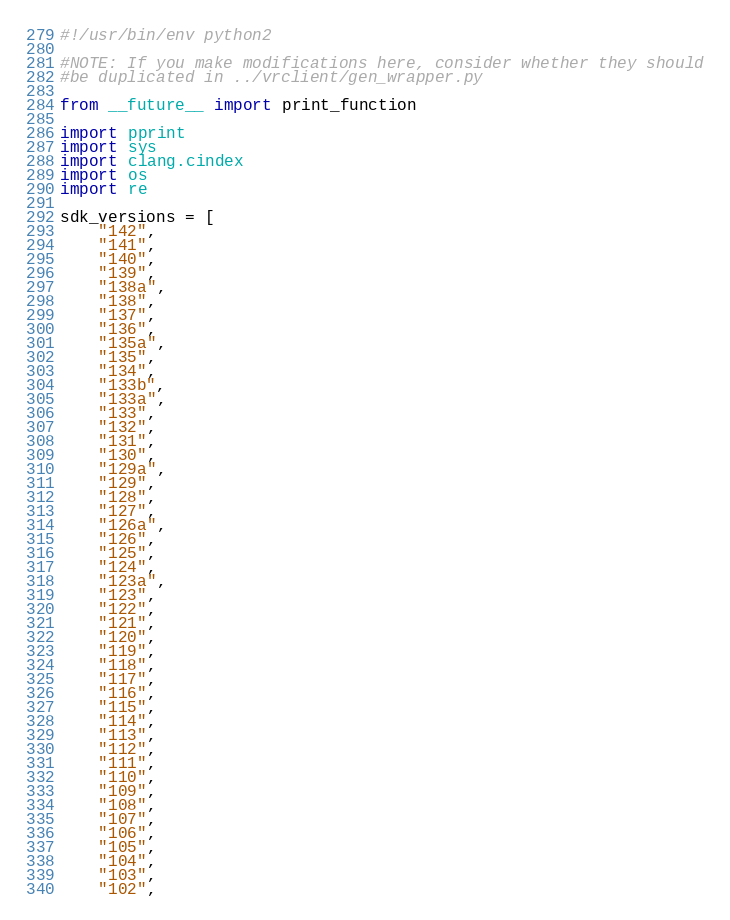Convert code to text. <code><loc_0><loc_0><loc_500><loc_500><_Python_>#!/usr/bin/env python2

#NOTE: If you make modifications here, consider whether they should
#be duplicated in ../vrclient/gen_wrapper.py

from __future__ import print_function

import pprint
import sys
import clang.cindex
import os
import re

sdk_versions = [
    "142",
    "141",
    "140",
    "139",
    "138a",
    "138",
    "137",
    "136",
    "135a",
    "135",
    "134",
    "133b",
    "133a",
    "133",
    "132",
    "131",
    "130",
    "129a",
    "129",
    "128",
    "127",
    "126a",
    "126",
    "125",
    "124",
    "123a",
    "123",
    "122",
    "121",
    "120",
    "119",
    "118",
    "117",
    "116",
    "115",
    "114",
    "113",
    "112",
    "111",
    "110",
    "109",
    "108",
    "107",
    "106",
    "105",
    "104",
    "103",
    "102",</code> 